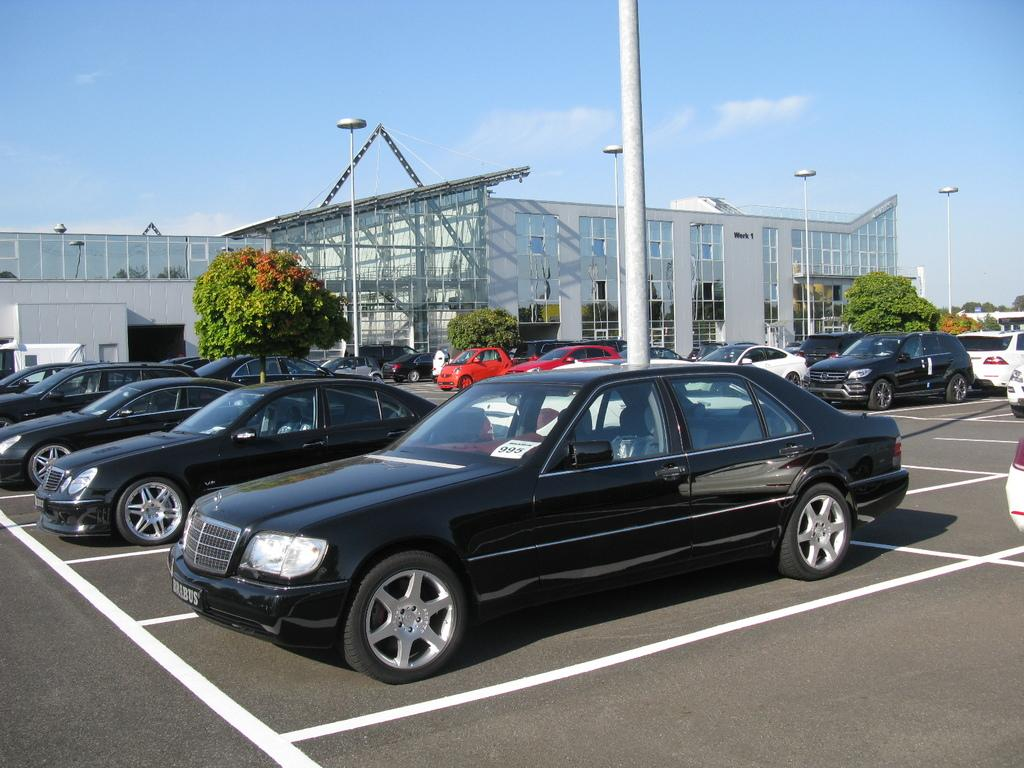What type of structures can be seen in the image? There are buildings with windows in the image. What material are the poles made of in the image? Metal poles are visible in the image. What type of transportation is present in the image? Vehicles are present in the image. What type of natural elements can be seen in the image? Trees are present in the image. What part of the natural environment is visible in the image? The sky is visible in the image. What type of instrument is being played by the person in the image? There is no person playing an instrument in the image. What letter is written on the side of the building in the image? There is no letter written on the side of any building in the image. 